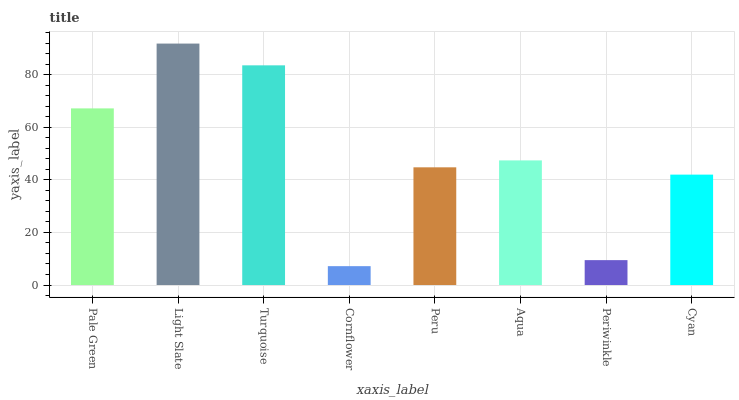Is Cornflower the minimum?
Answer yes or no. Yes. Is Light Slate the maximum?
Answer yes or no. Yes. Is Turquoise the minimum?
Answer yes or no. No. Is Turquoise the maximum?
Answer yes or no. No. Is Light Slate greater than Turquoise?
Answer yes or no. Yes. Is Turquoise less than Light Slate?
Answer yes or no. Yes. Is Turquoise greater than Light Slate?
Answer yes or no. No. Is Light Slate less than Turquoise?
Answer yes or no. No. Is Aqua the high median?
Answer yes or no. Yes. Is Peru the low median?
Answer yes or no. Yes. Is Cyan the high median?
Answer yes or no. No. Is Pale Green the low median?
Answer yes or no. No. 